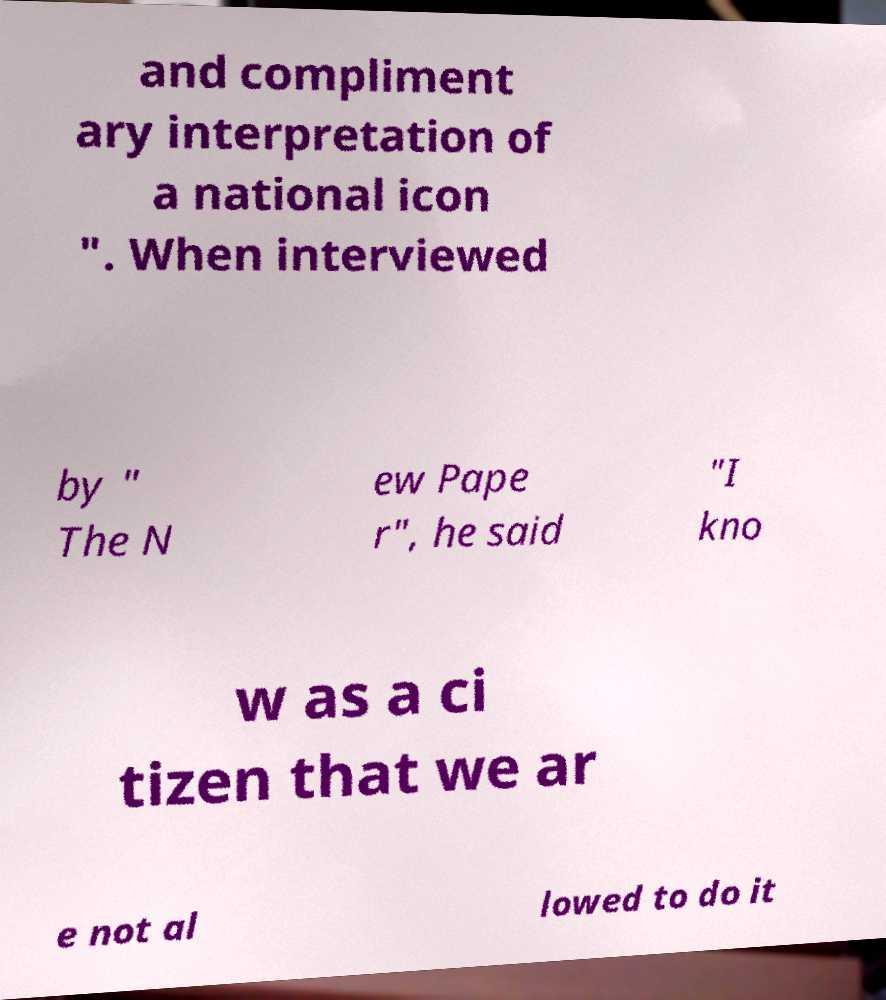Can you read and provide the text displayed in the image?This photo seems to have some interesting text. Can you extract and type it out for me? and compliment ary interpretation of a national icon ". When interviewed by " The N ew Pape r", he said "I kno w as a ci tizen that we ar e not al lowed to do it 